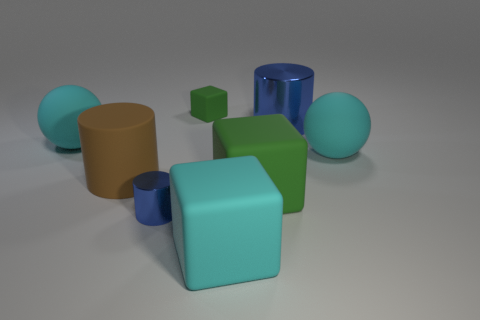What is the shape of the blue object that is the same size as the matte cylinder?
Your response must be concise. Cylinder. How many red objects are either large rubber blocks or big metal objects?
Your response must be concise. 0. What number of brown cylinders have the same size as the brown thing?
Make the answer very short. 0. What shape is the big matte thing that is the same color as the small matte object?
Keep it short and to the point. Cube. How many objects are tiny cyan metallic balls or large cyan matte blocks to the right of the tiny green matte cube?
Keep it short and to the point. 1. There is a cyan ball that is left of the brown matte cylinder; does it have the same size as the green cube that is behind the big blue shiny object?
Your answer should be very brief. No. What number of other green rubber objects have the same shape as the small rubber thing?
Your answer should be compact. 1. There is a small thing that is made of the same material as the big brown thing; what is its shape?
Offer a very short reply. Cube. The cube behind the large cyan rubber object behind the cyan ball that is on the right side of the small green cube is made of what material?
Your response must be concise. Rubber. Do the brown object and the cyan thing that is to the left of the tiny metal thing have the same size?
Your answer should be very brief. Yes. 